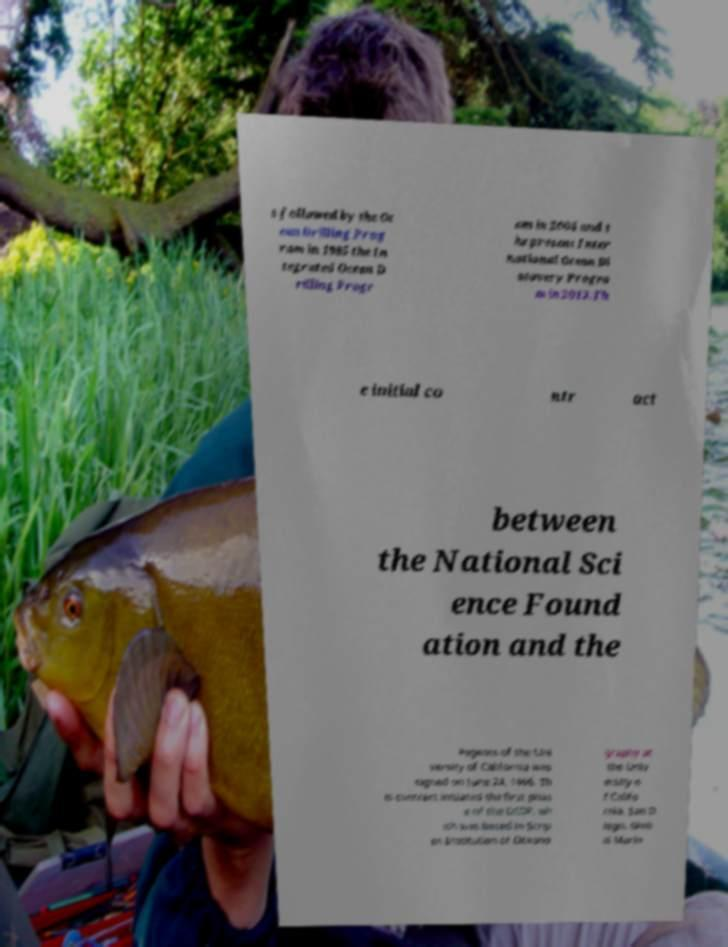I need the written content from this picture converted into text. Can you do that? s followed by the Oc ean Drilling Prog ram in 1985 the In tegrated Ocean D rilling Progr am in 2004 and t he present Inter national Ocean Di scovery Progra m in 2013.Th e initial co ntr act between the National Sci ence Found ation and the Regents of the Uni versity of California was signed on June 24, 1966. Th is contract initiated the first phas e of the DSDP, wh ich was based in Scrip ps Institution of Oceano graphy at the Univ ersity o f Califo rnia, San D iego. Glob al Marin 